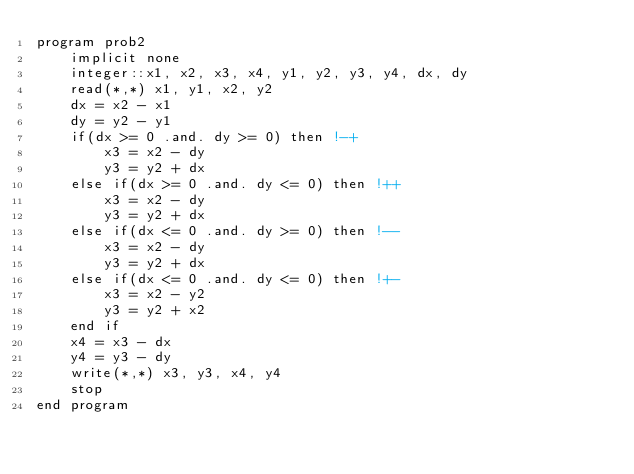Convert code to text. <code><loc_0><loc_0><loc_500><loc_500><_FORTRAN_>program prob2
    implicit none
    integer::x1, x2, x3, x4, y1, y2, y3, y4, dx, dy
    read(*,*) x1, y1, x2, y2
    dx = x2 - x1
    dy = y2 - y1
    if(dx >= 0 .and. dy >= 0) then !-+
        x3 = x2 - dy
        y3 = y2 + dx
    else if(dx >= 0 .and. dy <= 0) then !++
        x3 = x2 - dy
        y3 = y2 + dx
    else if(dx <= 0 .and. dy >= 0) then !--
        x3 = x2 - dy
        y3 = y2 + dx
    else if(dx <= 0 .and. dy <= 0) then !+-
        x3 = x2 - y2
        y3 = y2 + x2
    end if
    x4 = x3 - dx
    y4 = y3 - dy
    write(*,*) x3, y3, x4, y4
    stop
end program</code> 